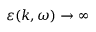Convert formula to latex. <formula><loc_0><loc_0><loc_500><loc_500>\varepsilon ( k , \omega ) \rightarrow \infty</formula> 